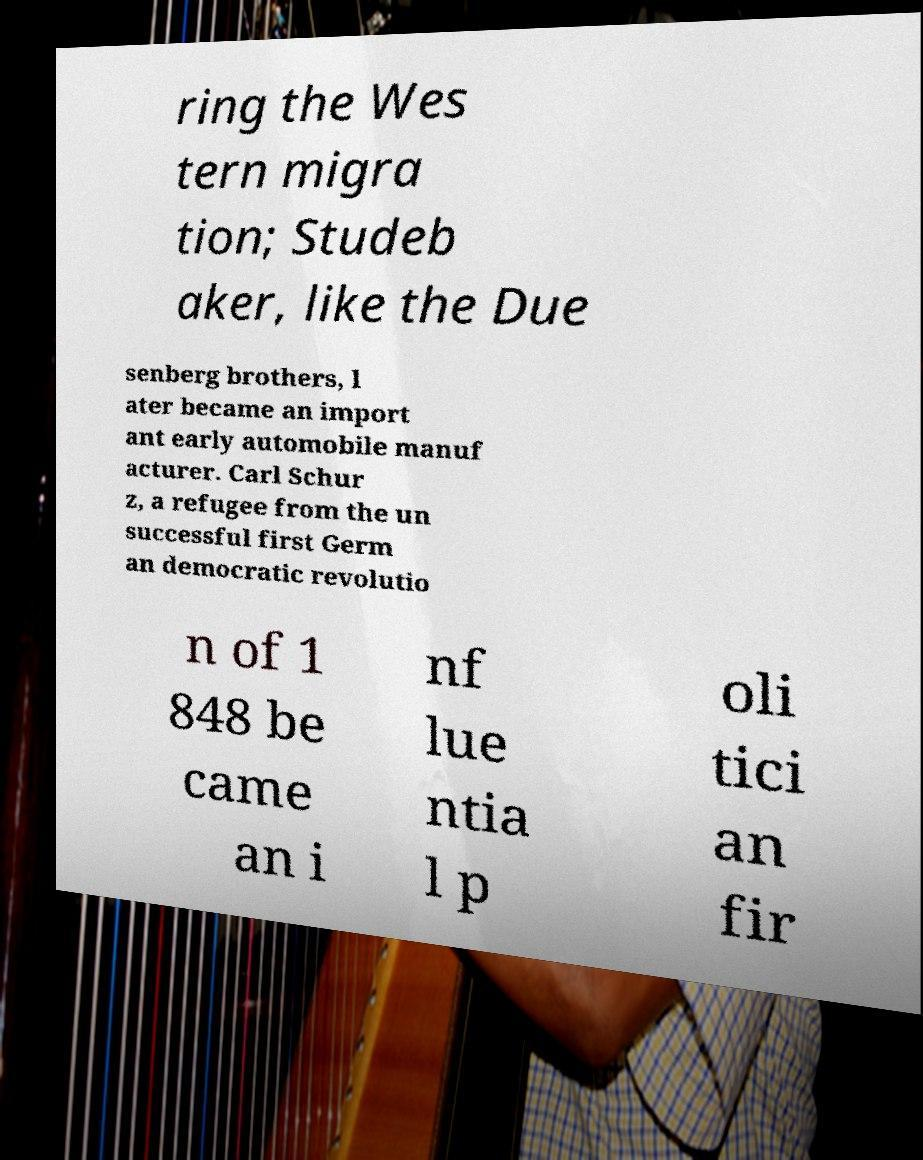Can you accurately transcribe the text from the provided image for me? ring the Wes tern migra tion; Studeb aker, like the Due senberg brothers, l ater became an import ant early automobile manuf acturer. Carl Schur z, a refugee from the un successful first Germ an democratic revolutio n of 1 848 be came an i nf lue ntia l p oli tici an fir 